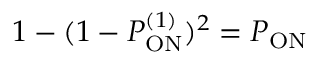<formula> <loc_0><loc_0><loc_500><loc_500>1 - ( 1 - P _ { O N } ^ { ( 1 ) } ) ^ { 2 } = P _ { O N }</formula> 